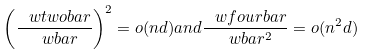<formula> <loc_0><loc_0><loc_500><loc_500>\left ( \frac { \ w t w o b a r } { \ w b a r } \right ) ^ { 2 } = o ( n d ) a n d \frac { \ w f o u r b a r } { \ w b a r ^ { 2 } } = o ( n ^ { 2 } d )</formula> 